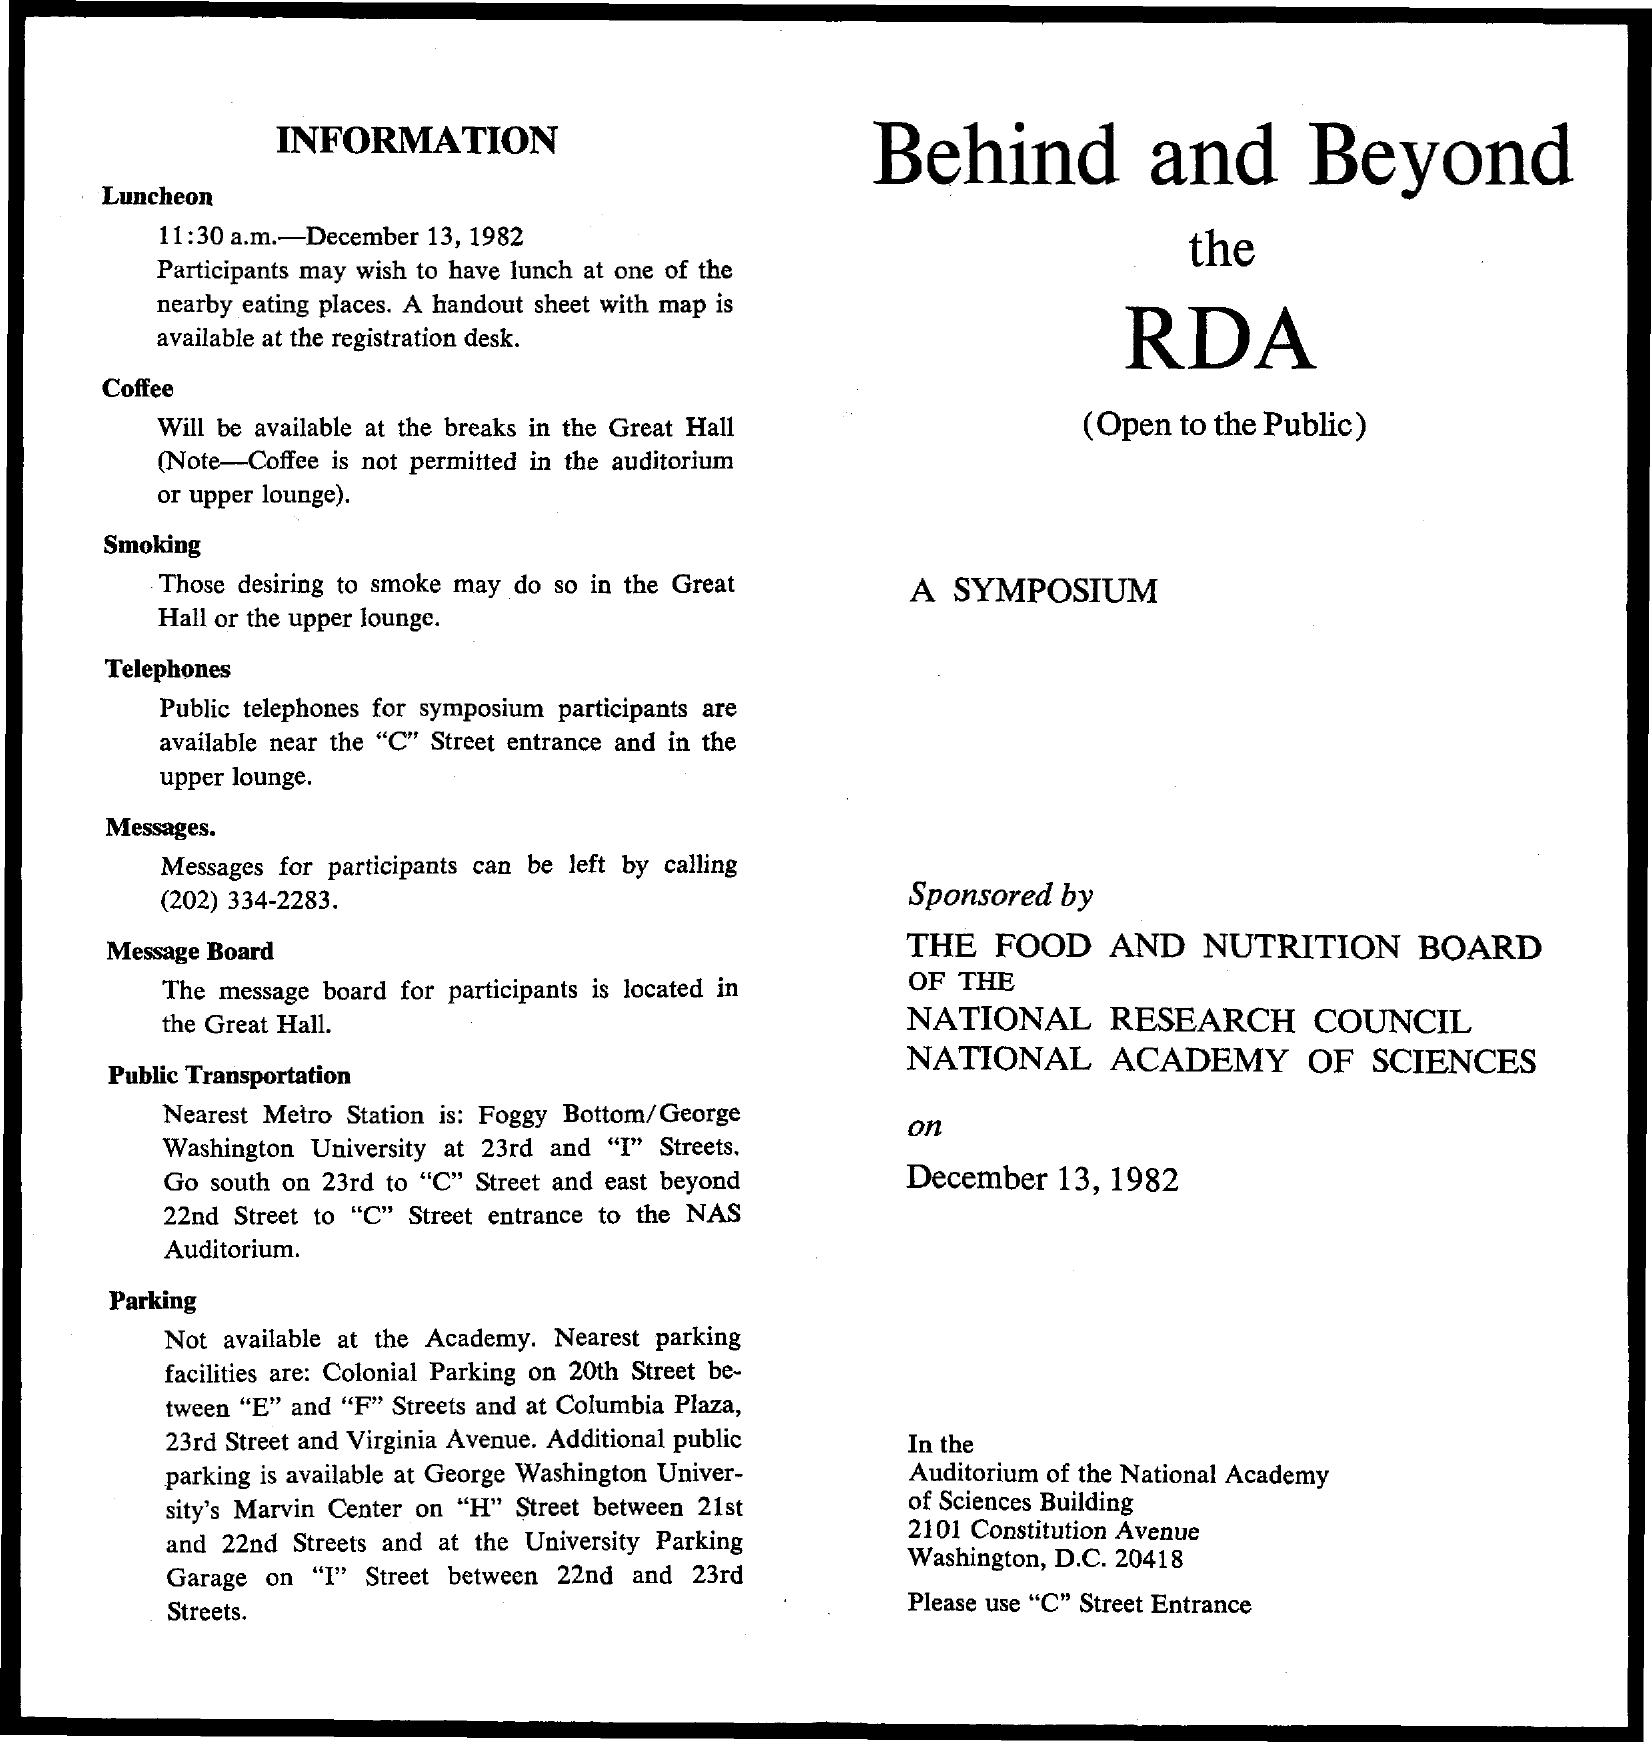List a handful of essential elements in this visual. The date mentioned is December 13, 1982. 